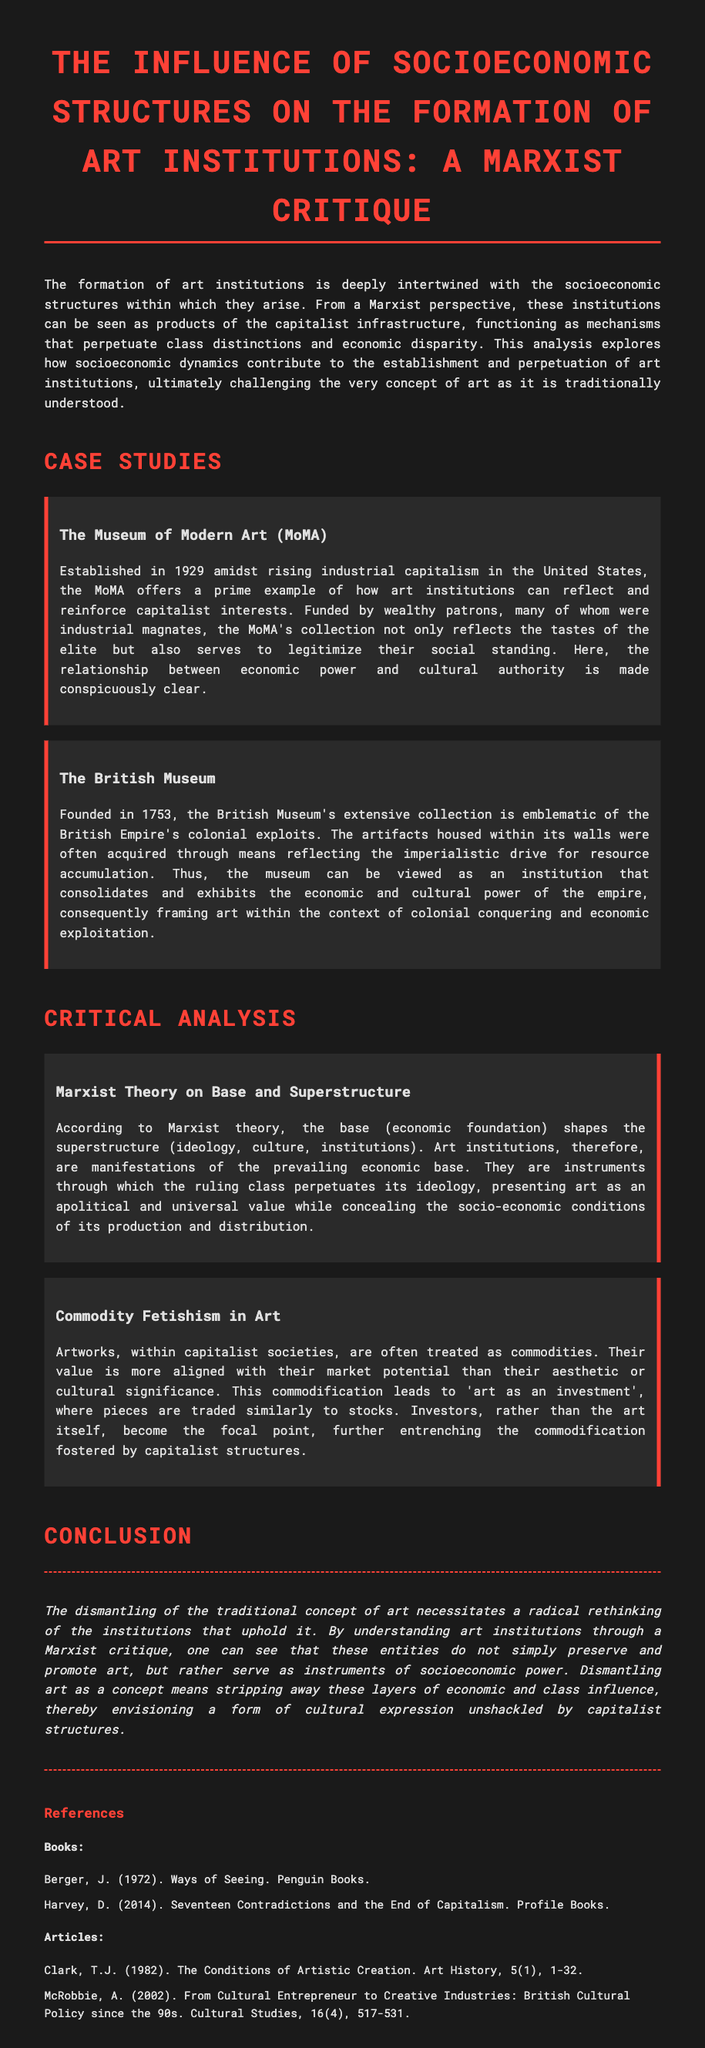What year was the Museum of Modern Art established? The Museum of Modern Art was established in 1929.
Answer: 1929 What does the British Museum's collection represent? The British Museum's collection represents the British Empire's colonial exploits.
Answer: Colonial exploits According to Marxist theory, what shapes the superstructure? According to Marxist theory, the base shapes the superstructure.
Answer: Base What does the term "commodity fetishism" refer to in the context of art? It refers to the treatment of artworks as commodities aligned with market potential.
Answer: Treatment as commodities What is the primary focus of investors in the art market? The primary focus of investors is more aligned with the market potential than aesthetic significance.
Answer: Market potential What color is used for the headings of the sections in the document? The headings of the sections are colored red, specifically #ff4136.
Answer: Red What does the document suggest about dismantling the traditional concept of art? It suggests that dismantling requires a radical rethinking of institutions that uphold art.
Answer: Radical rethinking Who is the author of "Ways of Seeing"? The author of "Ways of Seeing" is John Berger.
Answer: John Berger What mechanism do art institutions serve, according to the document? Art institutions serve as mechanisms that perpetuate class distinctions and economic disparity.
Answer: Mechanisms for class distinctions 